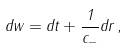Convert formula to latex. <formula><loc_0><loc_0><loc_500><loc_500>d w = d t + \frac { 1 } { c _ { - } } d r \, ,</formula> 